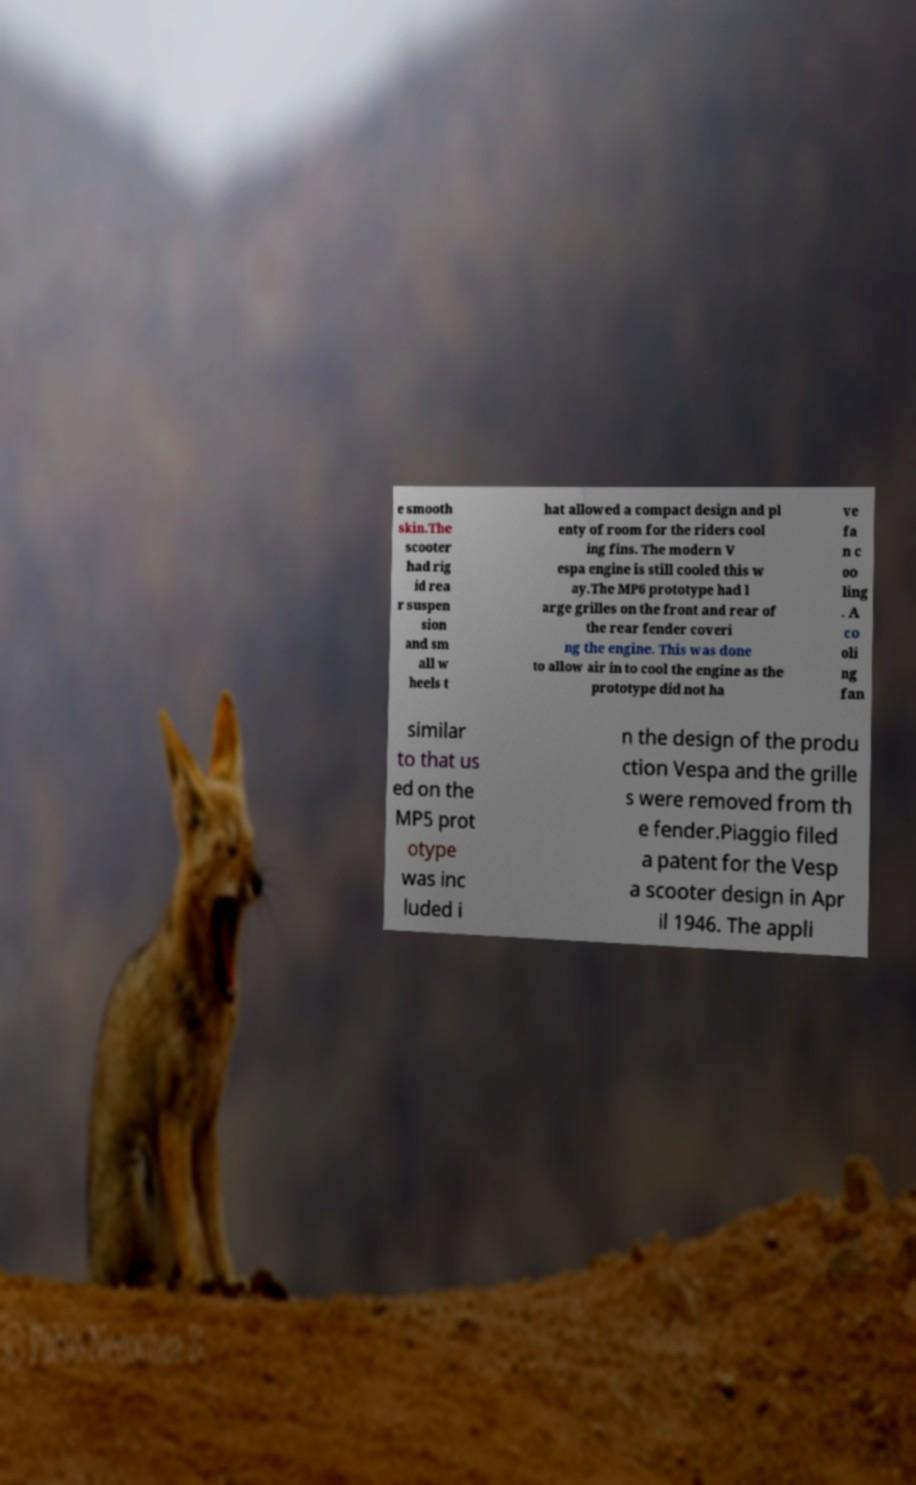Can you accurately transcribe the text from the provided image for me? e smooth skin.The scooter had rig id rea r suspen sion and sm all w heels t hat allowed a compact design and pl enty of room for the riders cool ing fins. The modern V espa engine is still cooled this w ay.The MP6 prototype had l arge grilles on the front and rear of the rear fender coveri ng the engine. This was done to allow air in to cool the engine as the prototype did not ha ve fa n c oo ling . A co oli ng fan similar to that us ed on the MP5 prot otype was inc luded i n the design of the produ ction Vespa and the grille s were removed from th e fender.Piaggio filed a patent for the Vesp a scooter design in Apr il 1946. The appli 